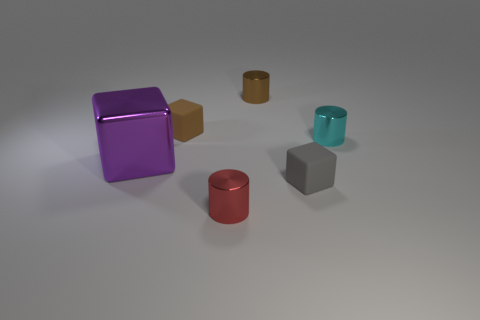Is there a red metallic ball that has the same size as the gray matte thing?
Provide a succinct answer. No. Is the number of tiny gray matte objects left of the tiny brown matte thing greater than the number of small cubes?
Ensure brevity in your answer.  No. How many small things are green matte cylinders or metallic objects?
Provide a short and direct response. 3. What number of purple objects have the same shape as the cyan metallic thing?
Your response must be concise. 0. What is the brown object that is left of the metal thing in front of the large block made of?
Give a very brief answer. Rubber. There is a rubber object behind the large purple metal thing; how big is it?
Offer a terse response. Small. How many gray objects are large blocks or cubes?
Give a very brief answer. 1. What material is the tiny brown thing that is the same shape as the small red metal object?
Make the answer very short. Metal. Are there an equal number of small brown cylinders in front of the small brown cube and purple blocks?
Give a very brief answer. No. There is a object that is both left of the small gray cube and in front of the large purple metallic thing; how big is it?
Provide a succinct answer. Small. 